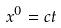Convert formula to latex. <formula><loc_0><loc_0><loc_500><loc_500>x ^ { 0 } = c t</formula> 